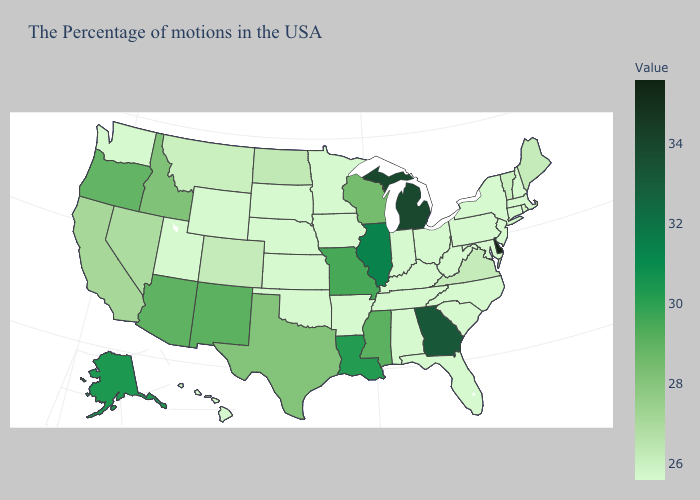Does New Mexico have a higher value than Maryland?
Write a very short answer. Yes. Among the states that border Connecticut , does Massachusetts have the highest value?
Quick response, please. No. Which states have the lowest value in the South?
Write a very short answer. Maryland, North Carolina, South Carolina, West Virginia, Florida, Kentucky, Alabama, Tennessee, Arkansas, Oklahoma. Which states have the lowest value in the Northeast?
Write a very short answer. Massachusetts, New Hampshire, Connecticut, New York, New Jersey, Pennsylvania. Does Missouri have the lowest value in the MidWest?
Write a very short answer. No. Which states hav the highest value in the South?
Quick response, please. Delaware. 